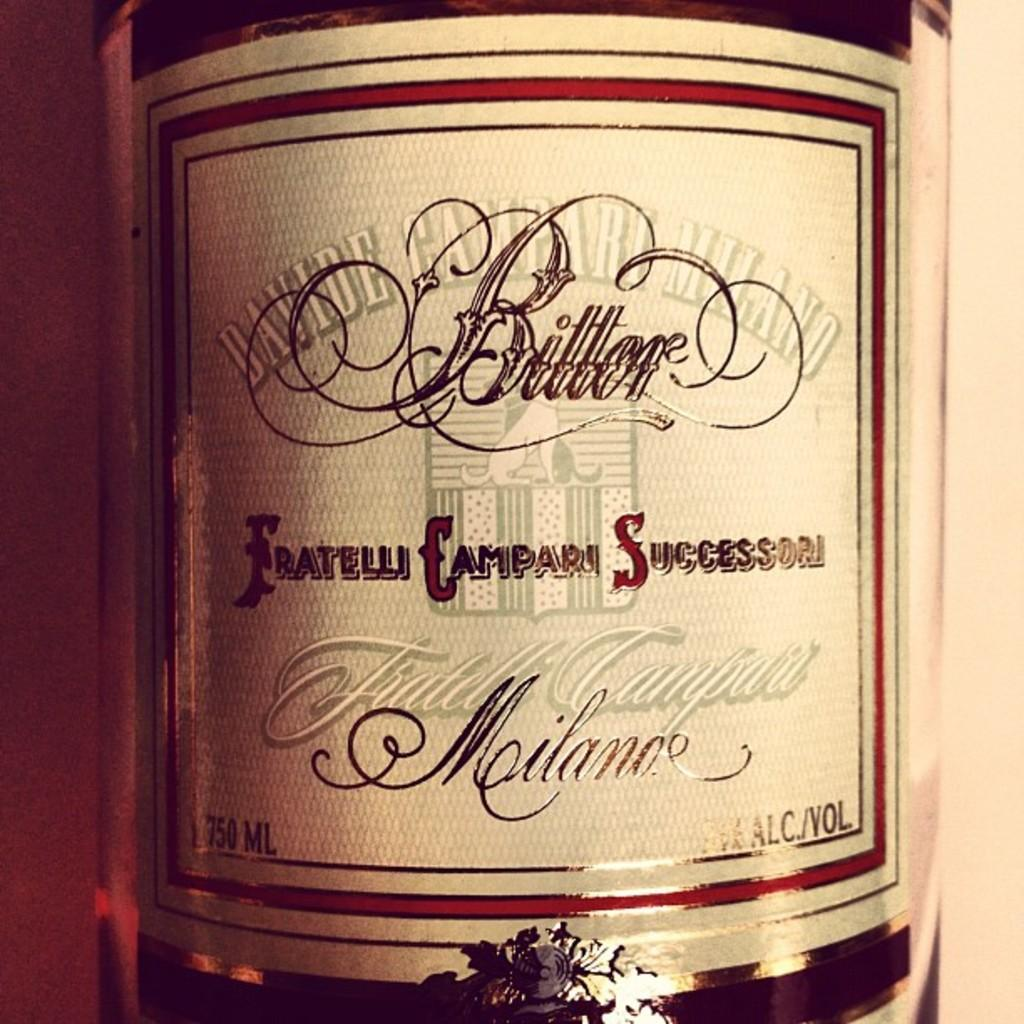<image>
Offer a succinct explanation of the picture presented. The label of a bottle of Fratelli Campari is white and red. 